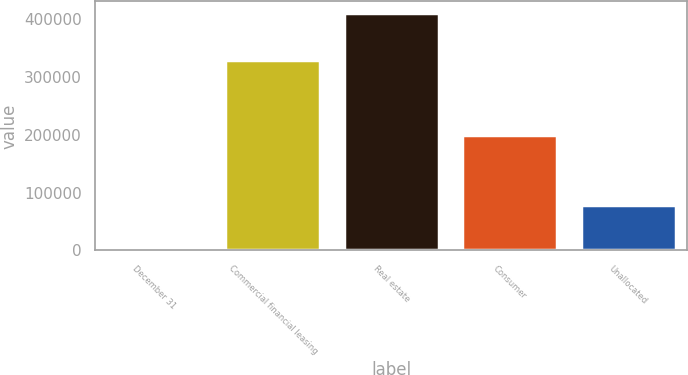<chart> <loc_0><loc_0><loc_500><loc_500><bar_chart><fcel>December 31<fcel>Commercial financial leasing<fcel>Real estate<fcel>Consumer<fcel>Unallocated<nl><fcel>2018<fcel>330055<fcel>410780<fcel>200564<fcel>78045<nl></chart> 